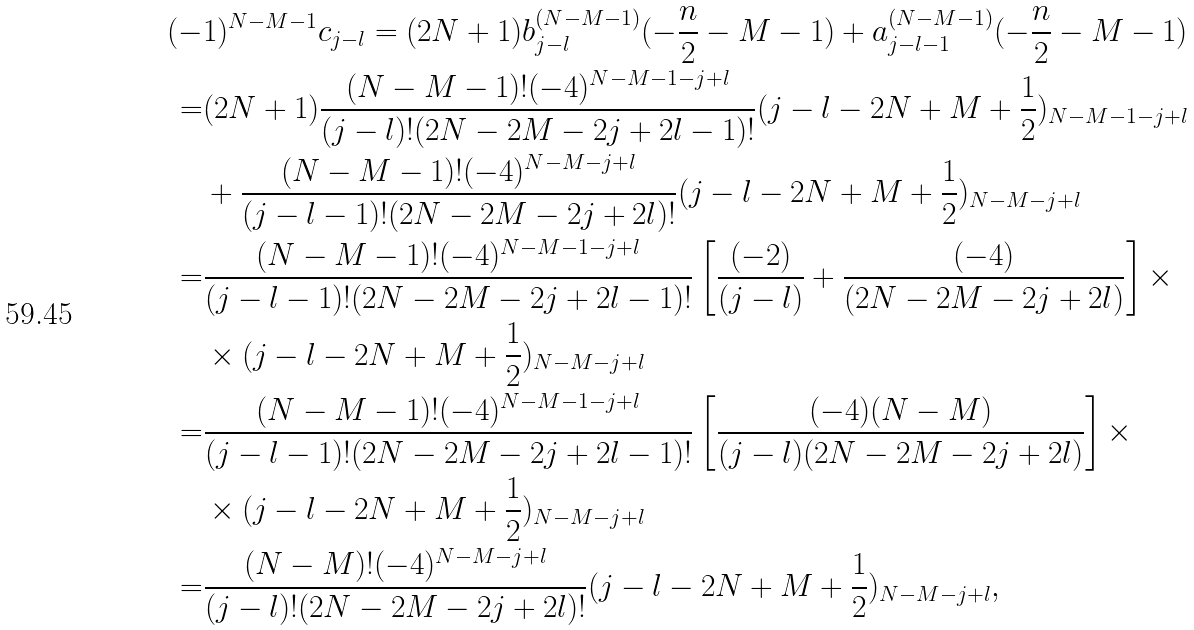Convert formula to latex. <formula><loc_0><loc_0><loc_500><loc_500>( - & 1 ) ^ { N - M - 1 } c _ { j - l } = ( 2 N + 1 ) b _ { j - l } ^ { ( N - M - 1 ) } ( - \frac { n } { 2 } - M - 1 ) + a _ { j - l - 1 } ^ { ( N - M - 1 ) } ( - \frac { n } { 2 } - M - 1 ) \\ = & ( 2 N + 1 ) \frac { ( N - M - 1 ) ! ( - 4 ) ^ { N - M - 1 - j + l } } { ( j - l ) ! ( 2 N - 2 M - 2 j + 2 l - 1 ) ! } ( j - l - 2 N + M + \frac { 1 } { 2 } ) _ { N - M - 1 - j + l } \\ & + \frac { ( N - M - 1 ) ! ( - 4 ) ^ { N - M - j + l } } { ( j - l - 1 ) ! ( 2 N - 2 M - 2 j + 2 l ) ! } ( j - l - 2 N + M + \frac { 1 } { 2 } ) _ { N - M - j + l } \\ = & \frac { ( N - M - 1 ) ! ( - 4 ) ^ { N - M - 1 - j + l } } { ( j - l - 1 ) ! ( 2 N - 2 M - 2 j + 2 l - 1 ) ! } \left [ \frac { ( - 2 ) } { ( j - l ) } + \frac { ( - 4 ) } { ( 2 N - 2 M - 2 j + 2 l ) } \right ] \times \\ & \times ( j - l - 2 N + M + \frac { 1 } { 2 } ) _ { N - M - j + l } \\ = & \frac { ( N - M - 1 ) ! ( - 4 ) ^ { N - M - 1 - j + l } } { ( j - l - 1 ) ! ( 2 N - 2 M - 2 j + 2 l - 1 ) ! } \left [ \frac { ( - 4 ) ( N - M ) } { ( j - l ) ( 2 N - 2 M - 2 j + 2 l ) } \right ] \times \\ & \times ( j - l - 2 N + M + \frac { 1 } { 2 } ) _ { N - M - j + l } \\ = & \frac { ( N - M ) ! ( - 4 ) ^ { N - M - j + l } } { ( j - l ) ! ( 2 N - 2 M - 2 j + 2 l ) ! } ( j - l - 2 N + M + \frac { 1 } { 2 } ) _ { N - M - j + l } ,</formula> 